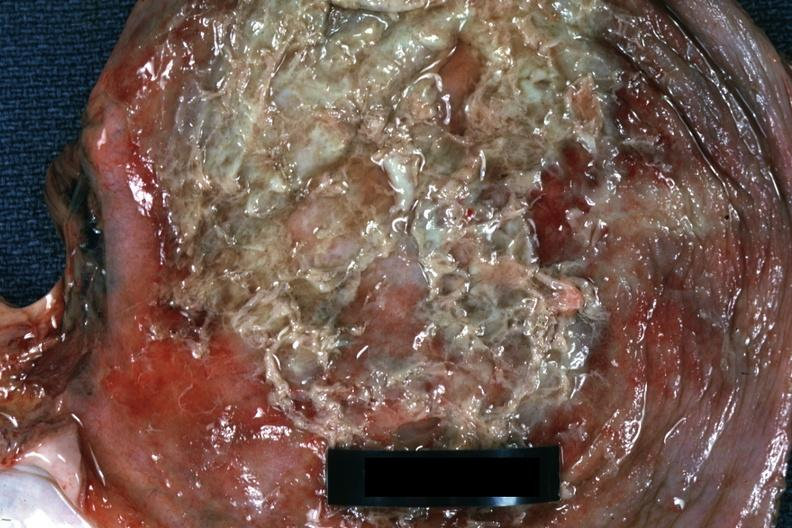s soft tissue present?
Answer the question using a single word or phrase. Yes 